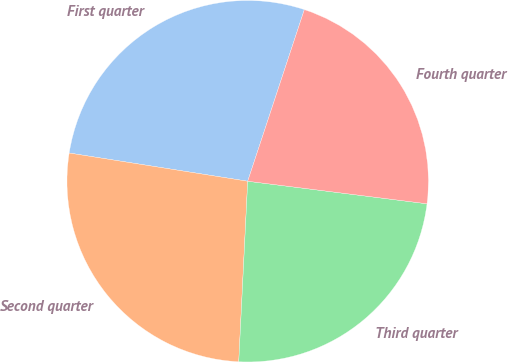Convert chart to OTSL. <chart><loc_0><loc_0><loc_500><loc_500><pie_chart><fcel>First quarter<fcel>Second quarter<fcel>Third quarter<fcel>Fourth quarter<nl><fcel>27.58%<fcel>26.71%<fcel>23.8%<fcel>21.92%<nl></chart> 